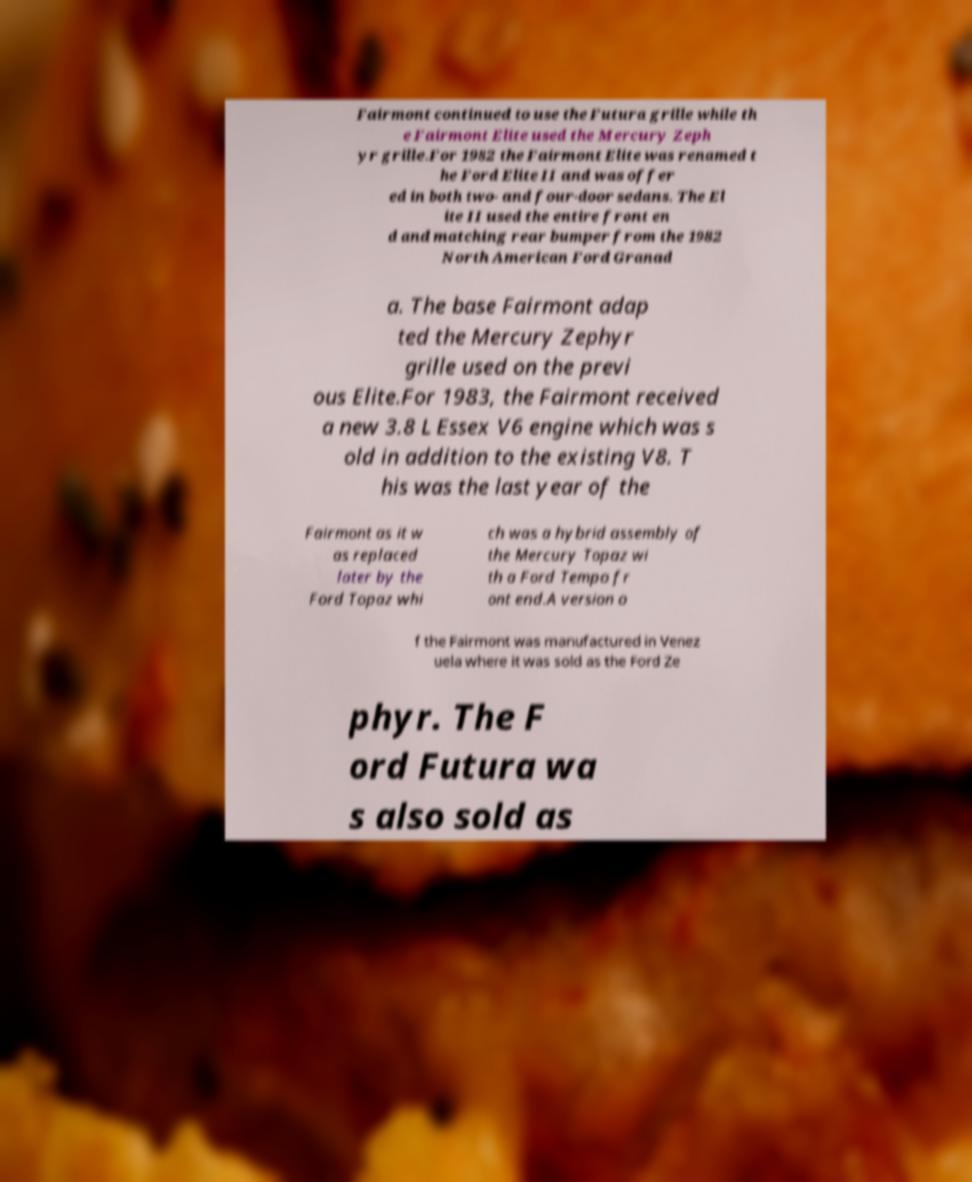Could you assist in decoding the text presented in this image and type it out clearly? Fairmont continued to use the Futura grille while th e Fairmont Elite used the Mercury Zeph yr grille.For 1982 the Fairmont Elite was renamed t he Ford Elite II and was offer ed in both two- and four-door sedans. The El ite II used the entire front en d and matching rear bumper from the 1982 North American Ford Granad a. The base Fairmont adap ted the Mercury Zephyr grille used on the previ ous Elite.For 1983, the Fairmont received a new 3.8 L Essex V6 engine which was s old in addition to the existing V8. T his was the last year of the Fairmont as it w as replaced later by the Ford Topaz whi ch was a hybrid assembly of the Mercury Topaz wi th a Ford Tempo fr ont end.A version o f the Fairmont was manufactured in Venez uela where it was sold as the Ford Ze phyr. The F ord Futura wa s also sold as 